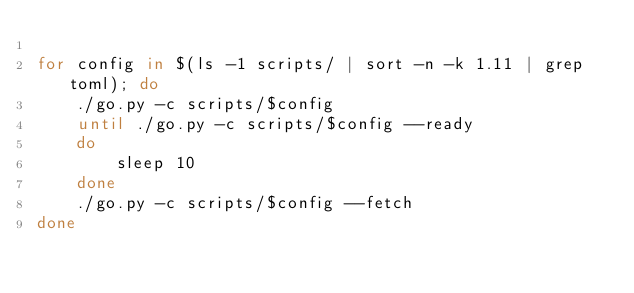Convert code to text. <code><loc_0><loc_0><loc_500><loc_500><_Bash_>
for config in $(ls -1 scripts/ | sort -n -k 1.11 | grep toml); do
	./go.py -c scripts/$config
	until ./go.py -c scripts/$config --ready
	do
		sleep 10
	done
	./go.py -c scripts/$config --fetch
done
</code> 